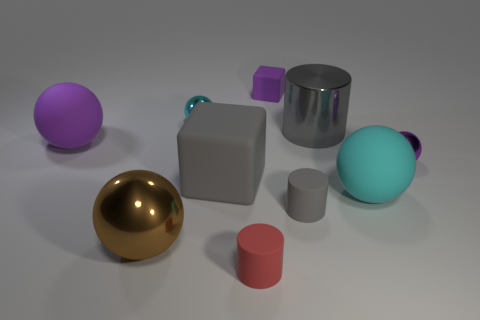There is a shiny cylinder; how many small purple objects are right of it? 1 